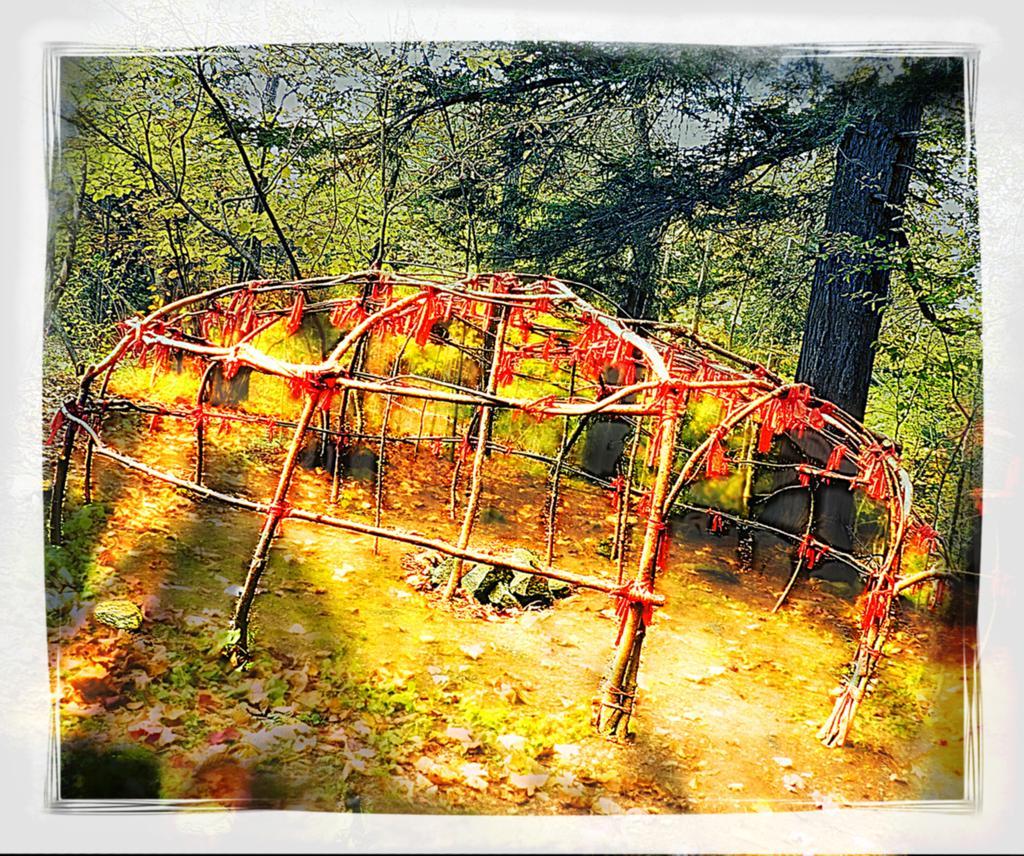How would you summarize this image in a sentence or two? In the center of the image we can see a fence. In the background there are trees. At the bottom there are leaves. 